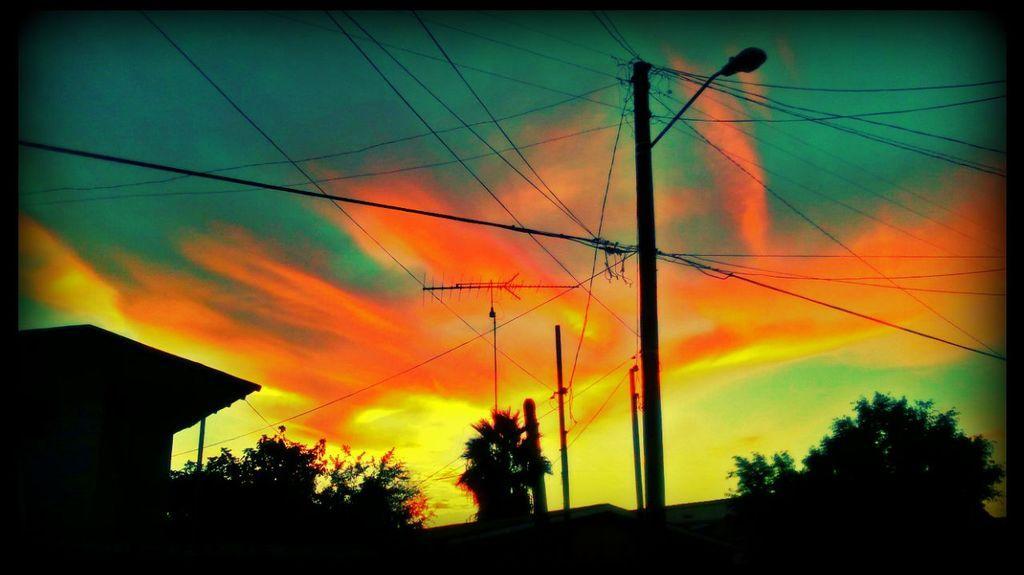Could you give a brief overview of what you see in this image? In the image we can see electric poles, electric wires and the trees. Here we can see light pole, house and the sky. 